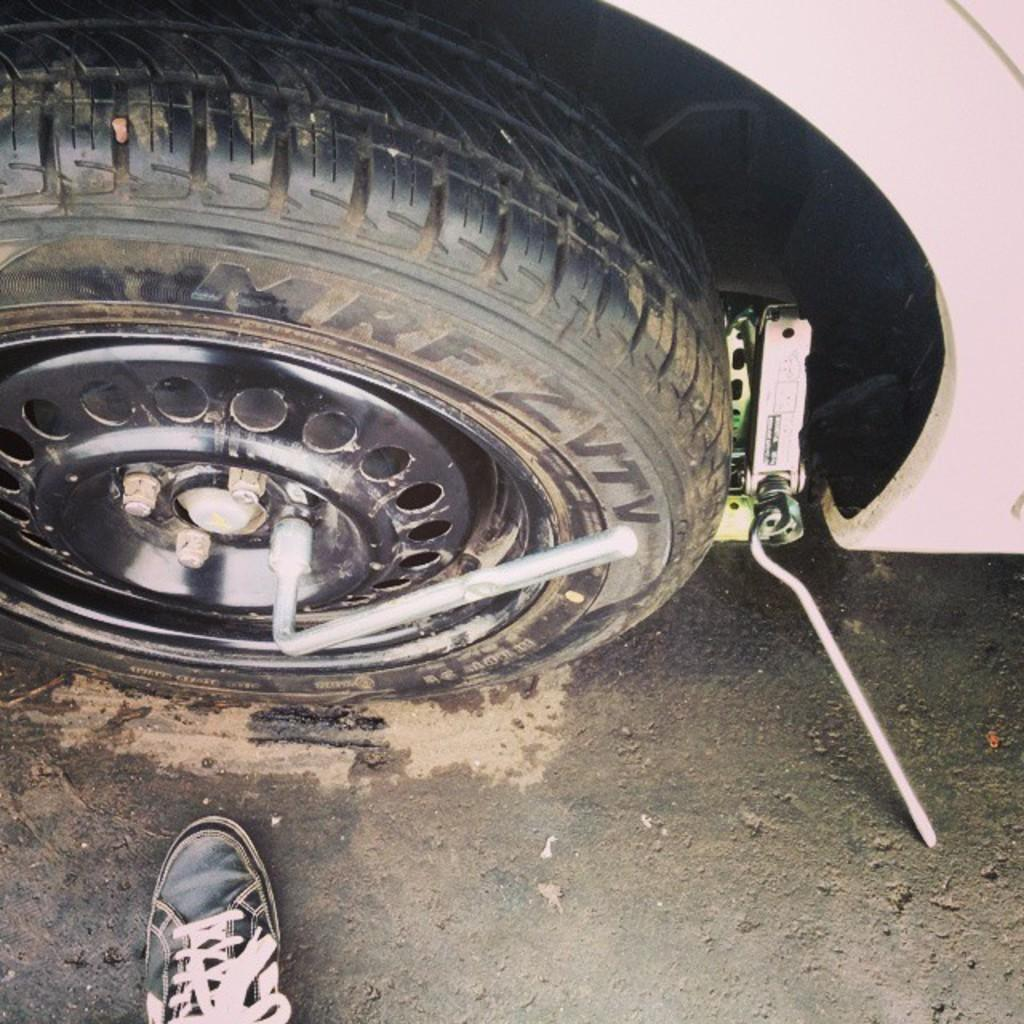What is the main object in the image? The main object in the image is a wheel of a vehicle. What is located in front of the wheel? There is a truncated shoe in front of the wheel. Where is the shop located in the image? There is no shop present in the image. What type of cup is being used by the governor in the image? There is no governor or cup present in the image. 